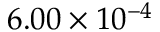<formula> <loc_0><loc_0><loc_500><loc_500>6 . 0 0 \times 1 0 ^ { - 4 }</formula> 